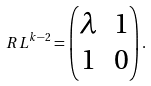<formula> <loc_0><loc_0><loc_500><loc_500>R L ^ { k - 2 } = \begin{pmatrix} \lambda & 1 \\ 1 & 0 \end{pmatrix} .</formula> 